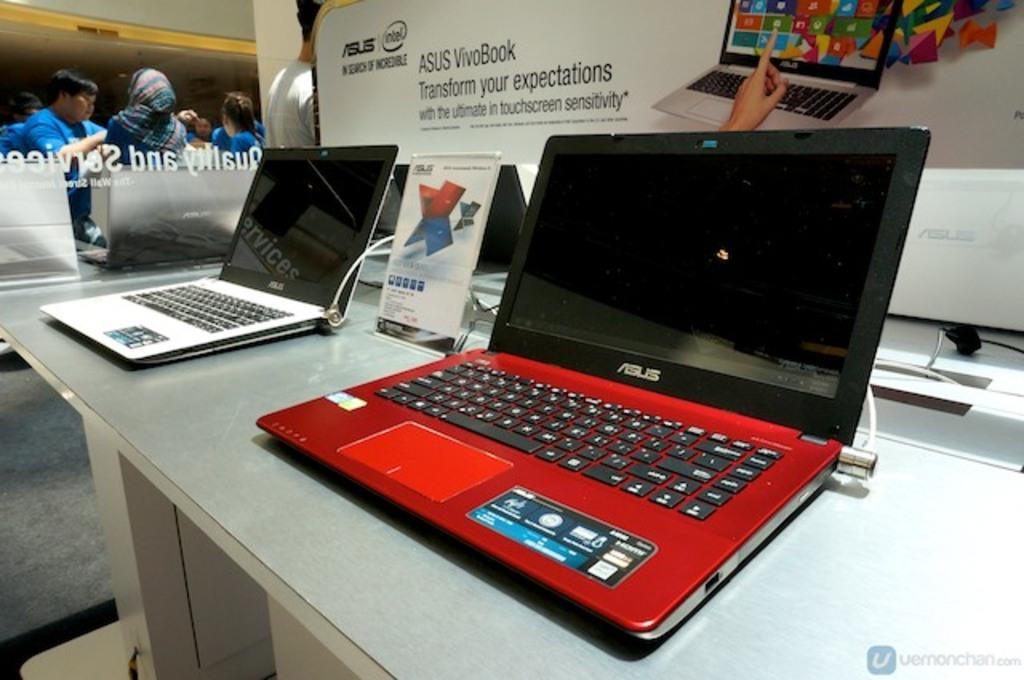<image>
Write a terse but informative summary of the picture. Two laptops sit in front of a sign that has the intel logo on it. 